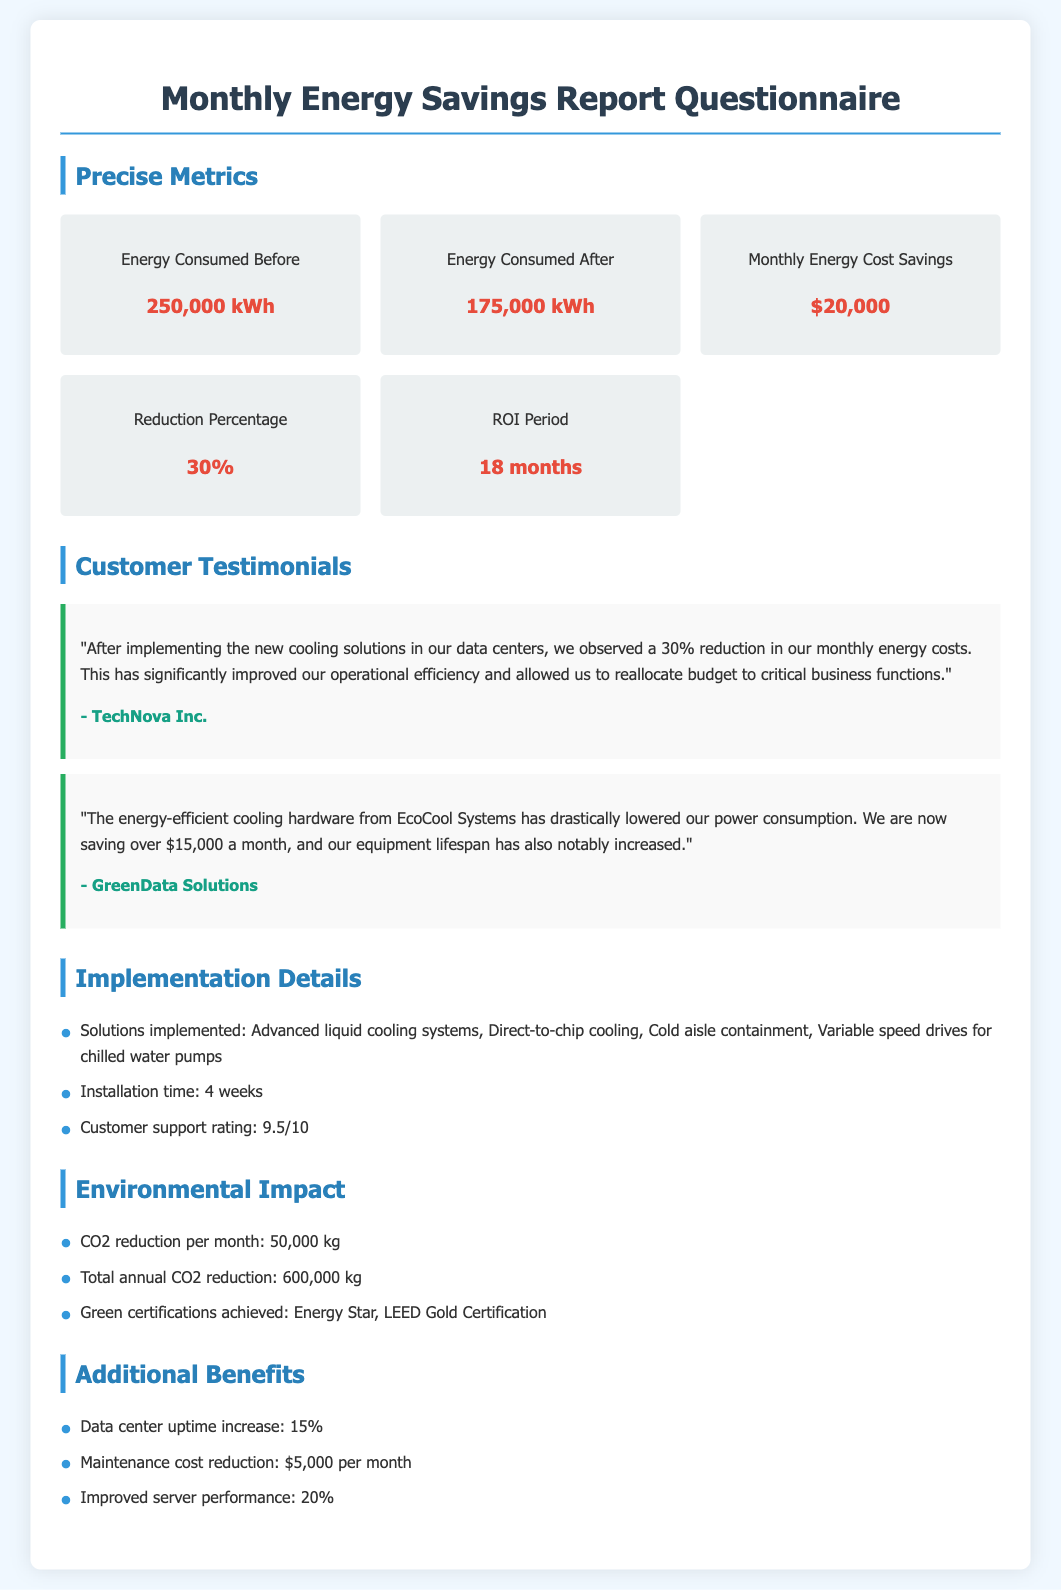What was the energy consumed before implementing cooling solutions? The energy consumed before was listed in the metrics section as 250,000 kWh.
Answer: 250,000 kWh What is the monthly energy cost savings reported after the implementation? The monthly energy cost savings is explicitly stated as $20,000 in the report.
Answer: $20,000 What percentage reduction in energy consumption was achieved? The document indicates a reduction percentage of 30% after the cooling solutions were implemented.
Answer: 30% How long is the ROI period for the cooling solutions? The ROI period is mentioned as 18 months in the metrics section of the report.
Answer: 18 months Which organization reported a $15,000 savings due to the cooling solutions? The testimonial from GreenData Solutions mentions their savings of over $15,000 a month.
Answer: GreenData Solutions What was the installation time for the cooling solutions? The installation time is provided as 4 weeks in the implementation details section.
Answer: 4 weeks How much CO2 reduction occurs per month with the new cooling solutions? The report specifies a CO2 reduction of 50,000 kg per month.
Answer: 50,000 kg What is the customer support rating mentioned in the report? According to the implementation details, the customer support rating is 9.5 out of 10.
Answer: 9.5/10 What increase in data center uptime is reported? The additional benefits section states a data center uptime increase of 15%.
Answer: 15% 